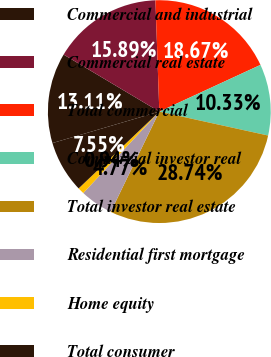Convert chart to OTSL. <chart><loc_0><loc_0><loc_500><loc_500><pie_chart><fcel>Commercial and industrial<fcel>Commercial real estate<fcel>Total commercial<fcel>Commercial investor real<fcel>Total investor real estate<fcel>Residential first mortgage<fcel>Home equity<fcel>Total consumer<nl><fcel>13.11%<fcel>15.89%<fcel>18.67%<fcel>10.33%<fcel>28.74%<fcel>4.77%<fcel>0.94%<fcel>7.55%<nl></chart> 